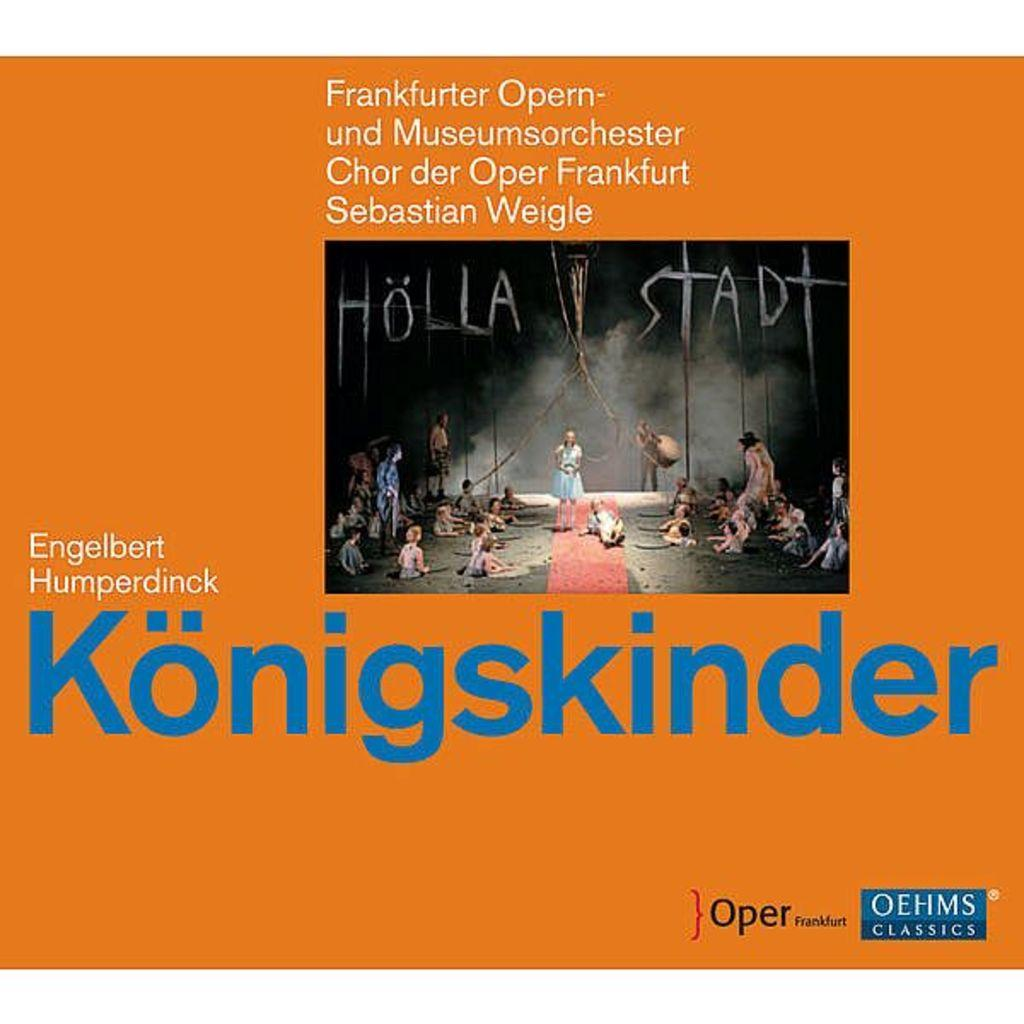<image>
Render a clear and concise summary of the photo. Album cover that says Holla Stadt in white. 